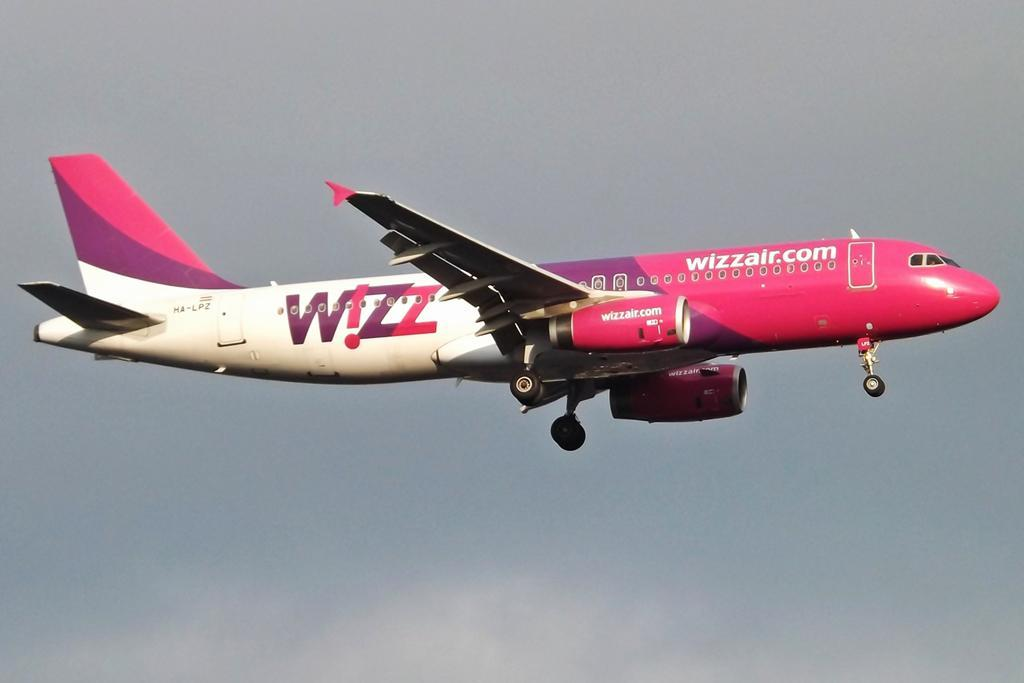Provide a one-sentence caption for the provided image. A plane has the website wizzair.com on the side of it. 